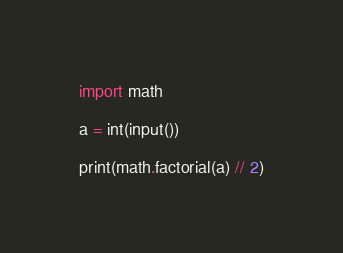<code> <loc_0><loc_0><loc_500><loc_500><_Python_>import math

a = int(input())

print(math.factorial(a) // 2)
</code> 